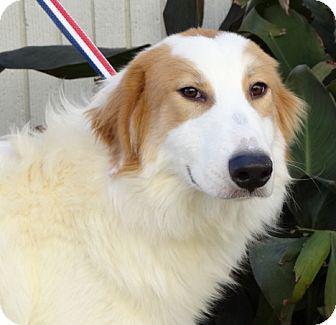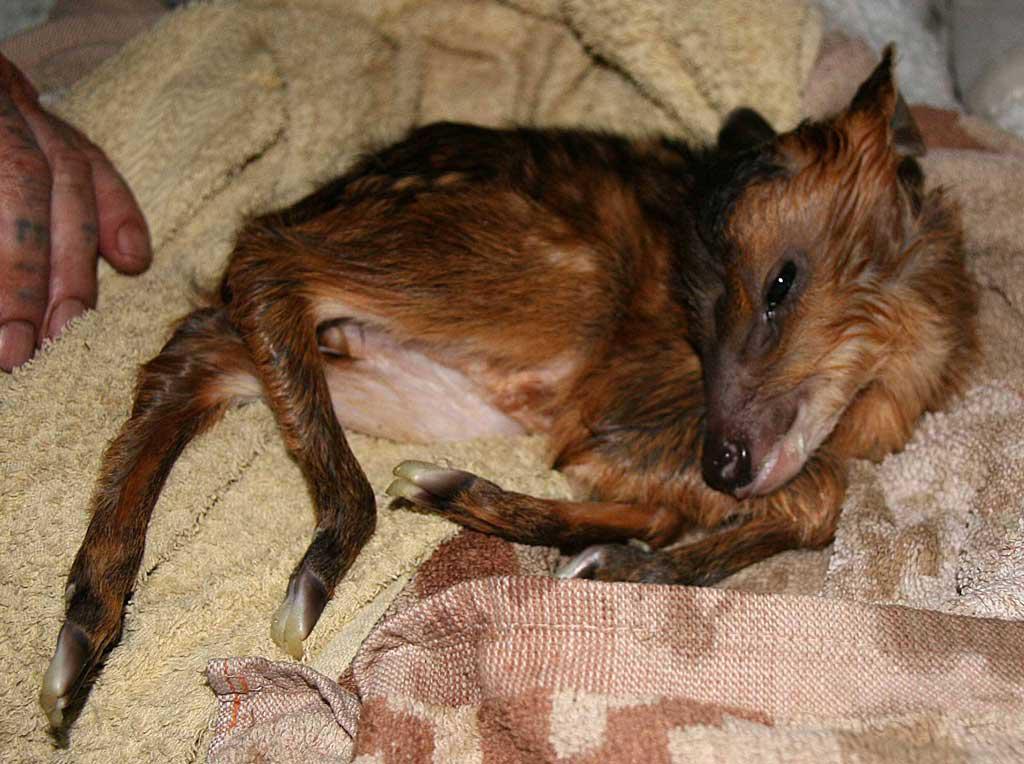The first image is the image on the left, the second image is the image on the right. Evaluate the accuracy of this statement regarding the images: "The dog in one of the images is lying down on a piece of furniture.". Is it true? Answer yes or no. Yes. 